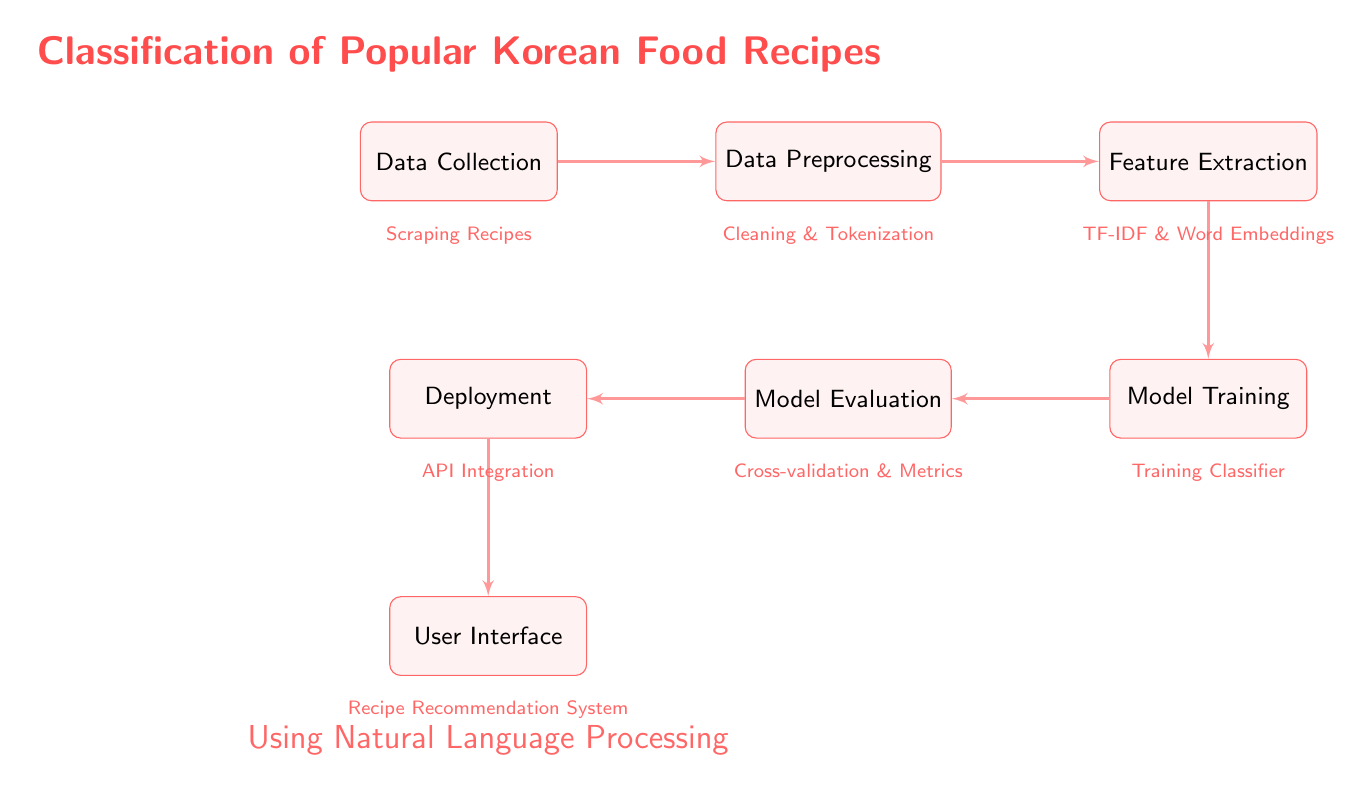What is the first step in the diagram? The first step is labeled as "Data Collection," which is the starting point of the process in the diagram.
Answer: Data Collection How many main blocks are present in the diagram? Counting the blocks shown in the diagram, there are a total of seven main blocks connected by arrows.
Answer: Seven What process comes after Feature Extraction? Following the Feature Extraction block, the next block in the sequence is Model Training, indicating the flow of the process.
Answer: Model Training What technique is mentioned under Data Preprocessing? The note associated with Data Preprocessing states "Cleaning & Tokenization," which outlines the specific techniques used during this step.
Answer: Cleaning & Tokenization Which step includes "Cross-validation & Metrics"? The block that includes "Cross-validation & Metrics" is directly linked to Model Evaluation, indicating this is where the evaluation takes place.
Answer: Model Evaluation What is the final output of the flow in the diagram? The last block in the flow is User Interface, which represents the final output where users can interact with the system.
Answer: User Interface In what stage is the classifier trained? The classifier is trained during the Model Training stage, as outlined in the diagram, reflecting when the model learns from the feature data.
Answer: Model Training What will the system recommend to users? The note under the User Interface specifies "Recipe Recommendation System," indicating the function of the final output in the context of Korean food recipes.
Answer: Recipe Recommendation System 